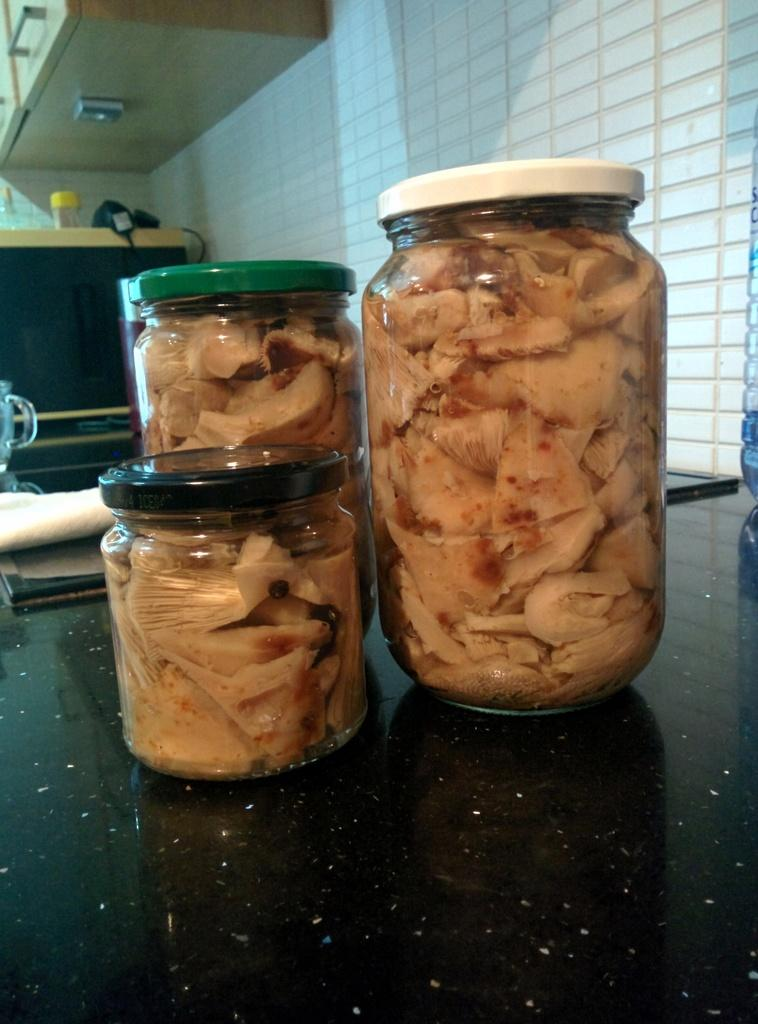How many jars are on the platform in the image? There are three jars on a platform in the image. What is inside the jars? There is food inside the jars. What can be seen in the background of the image? There is a wall and a cupboard in the background of the image, as well as other things visible. What type of trees can be seen growing inside the jars? There are no trees visible in the image, let alone growing inside the jars. 